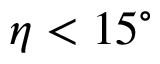Convert formula to latex. <formula><loc_0><loc_0><loc_500><loc_500>\eta < 1 5 ^ { \circ }</formula> 